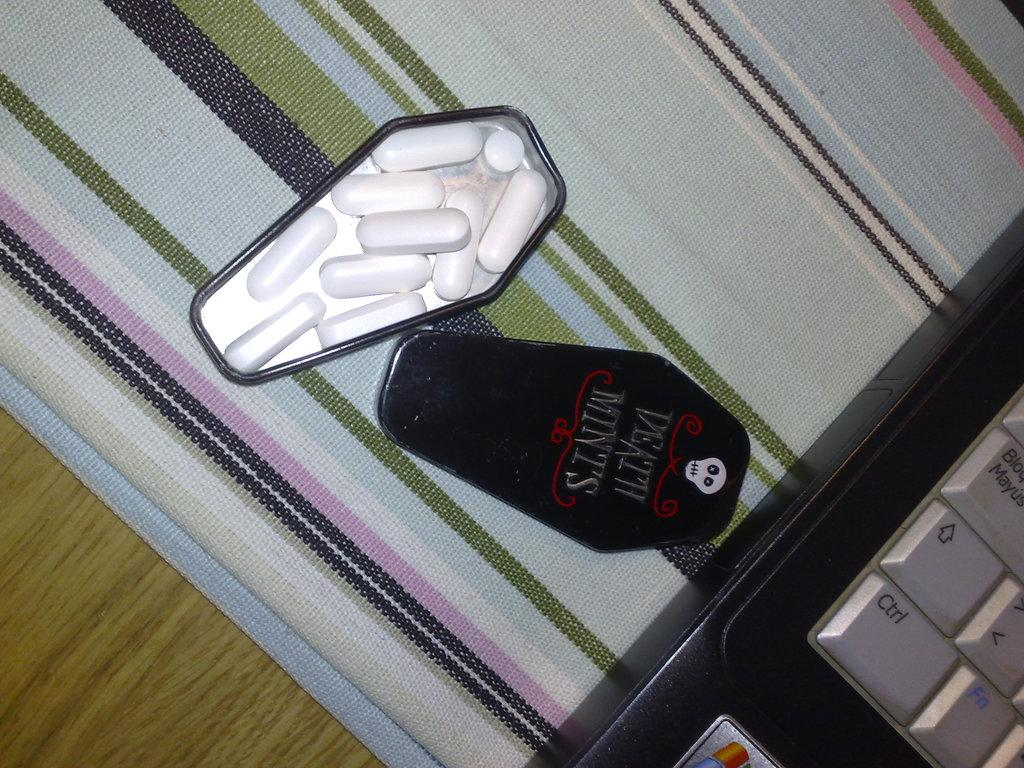<image>
Share a concise interpretation of the image provided. Box of Death Mints with a skull on it next to a black laptop. 